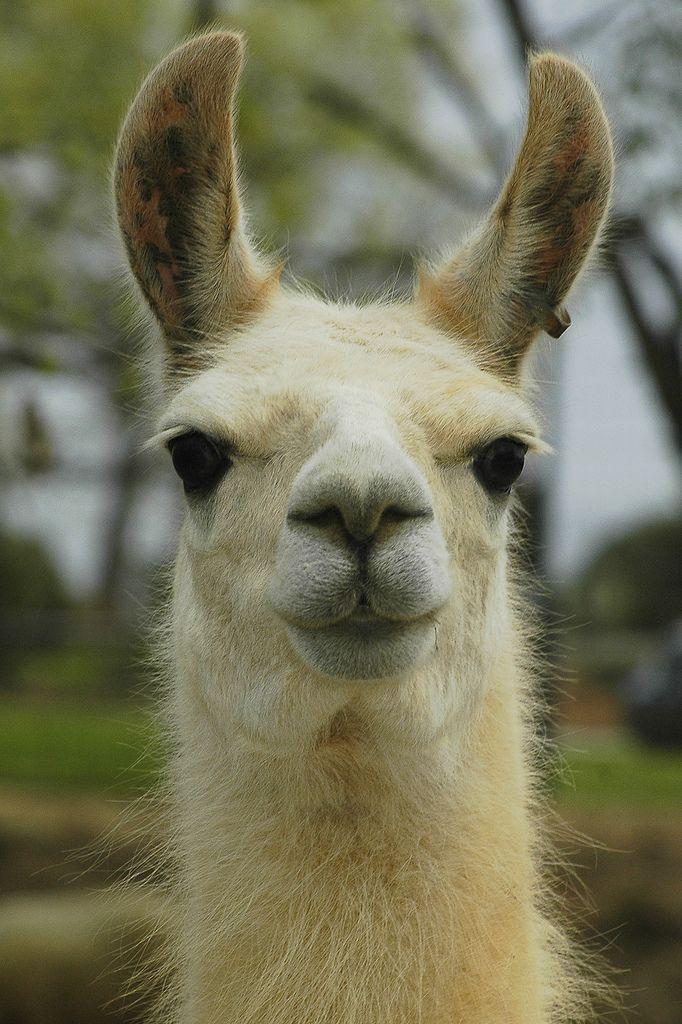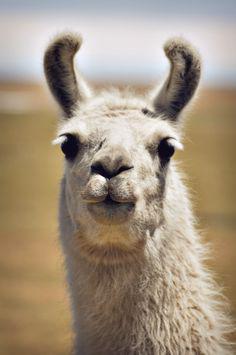The first image is the image on the left, the second image is the image on the right. Examine the images to the left and right. Is the description "One image shows a forward-facing llama with dark ears and protruding lower teeth, and the other image shows a forward-facing white llama." accurate? Answer yes or no. No. 